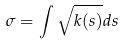<formula> <loc_0><loc_0><loc_500><loc_500>\sigma = \int \sqrt { k ( s ) } d s</formula> 